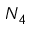Convert formula to latex. <formula><loc_0><loc_0><loc_500><loc_500>N _ { 4 }</formula> 